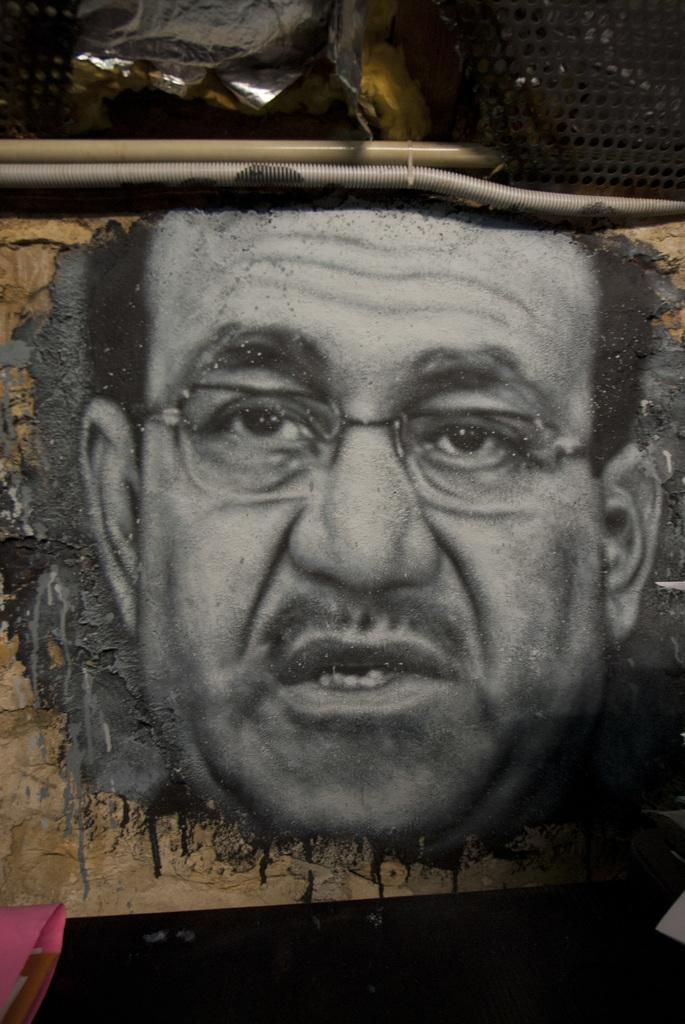What is the main subject of the image? There is a picture of a person in the image. Can you describe any other objects or elements in the image? There are other objects present in the background of the image. How many baskets are hanging from the street in the image? There is no mention of a street or baskets in the image, so we cannot determine the presence or number of baskets. 